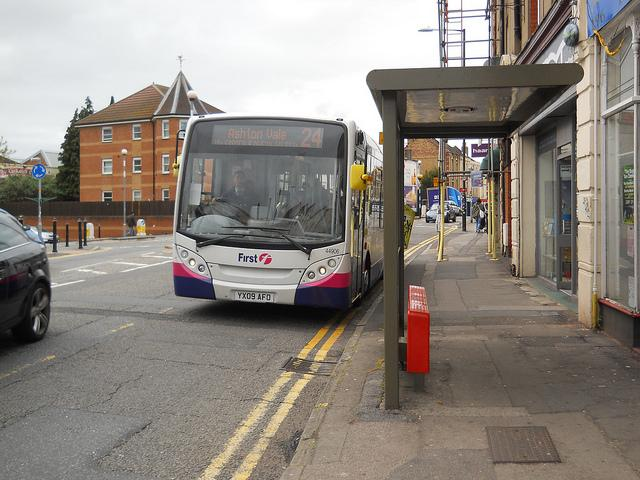Where is this bus headed next? ashton vale 